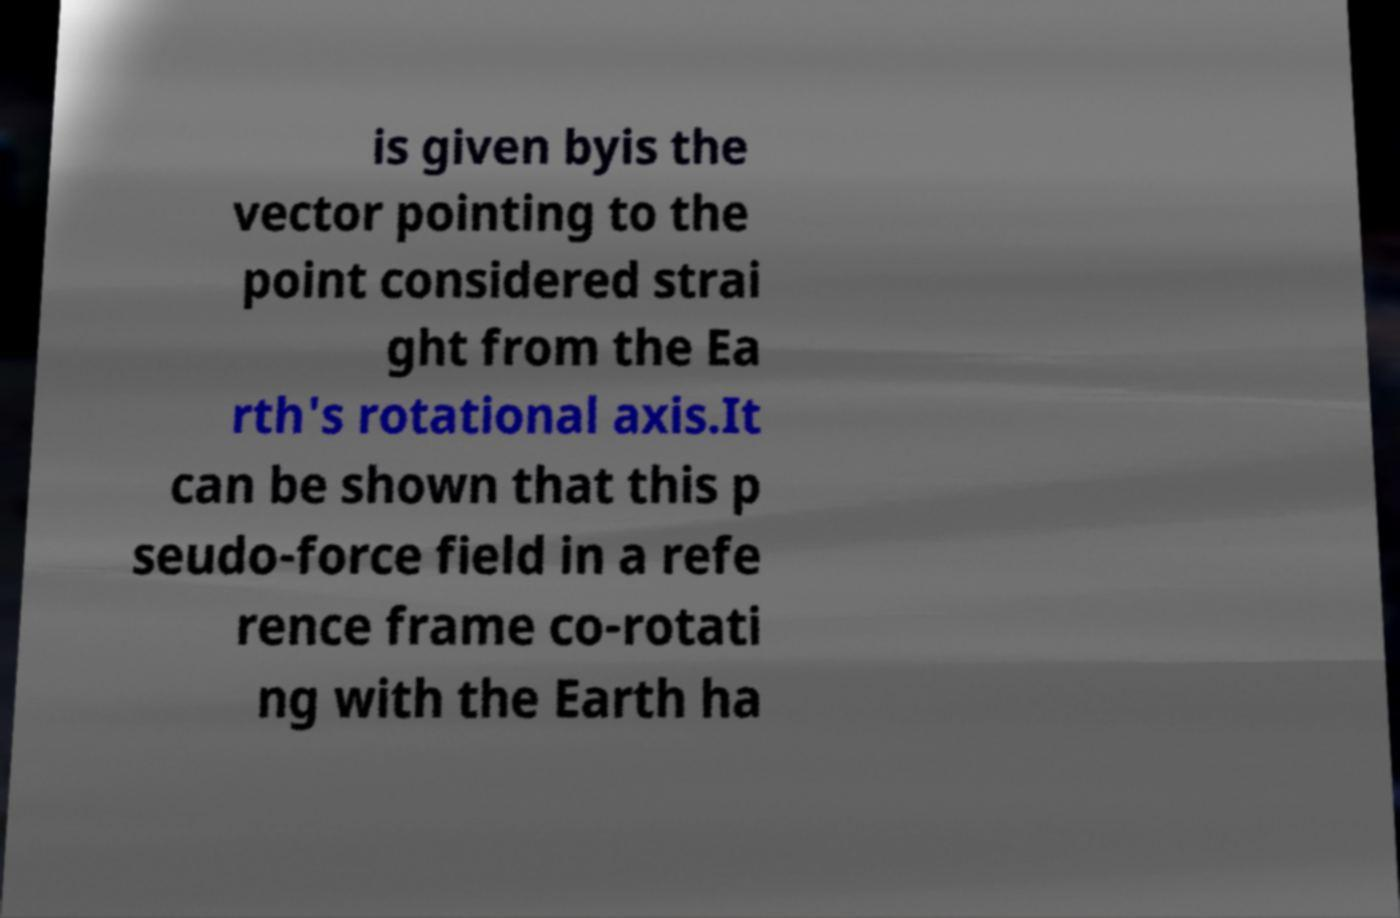Please identify and transcribe the text found in this image. is given byis the vector pointing to the point considered strai ght from the Ea rth's rotational axis.It can be shown that this p seudo-force field in a refe rence frame co-rotati ng with the Earth ha 